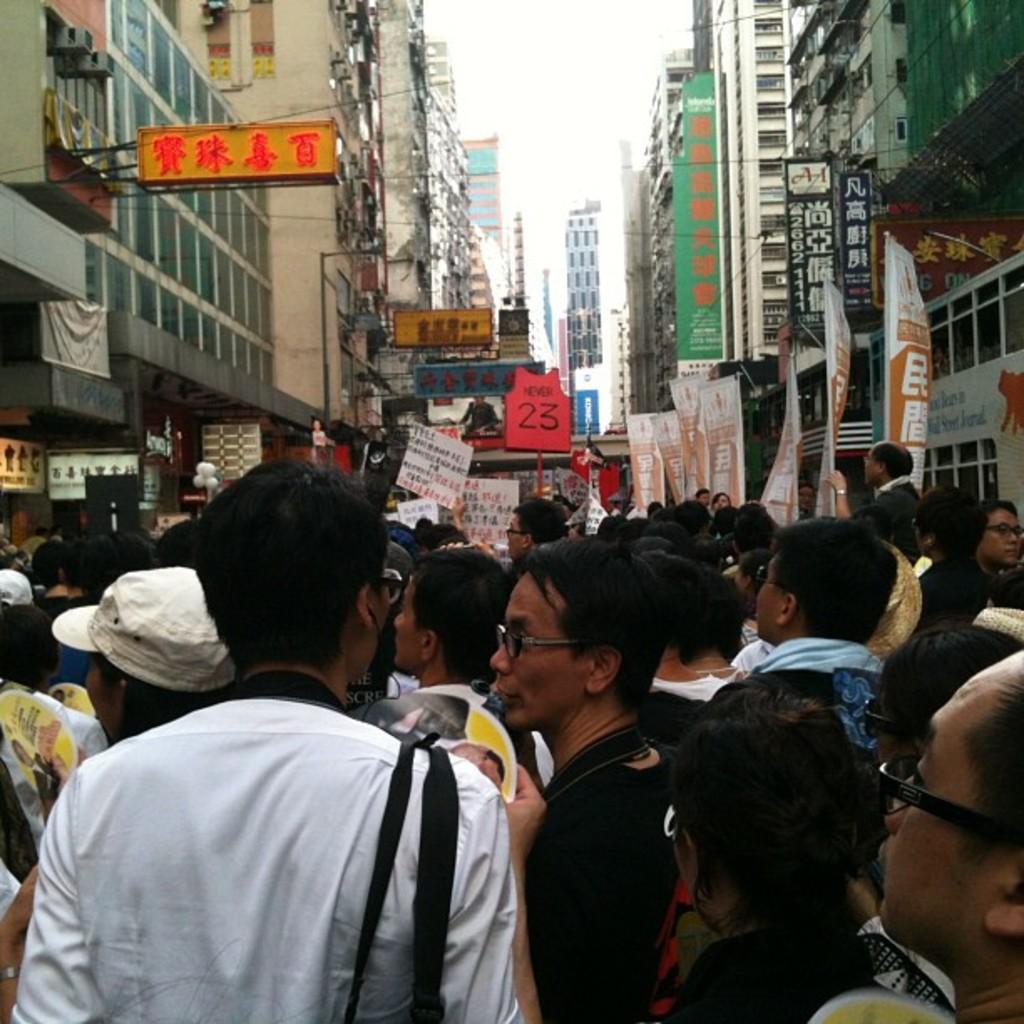Please provide a concise description of this image. In this picture there are many people walking in the lane. On both the side we can see the building and some shops with naming board. In the background there are some buildings. 